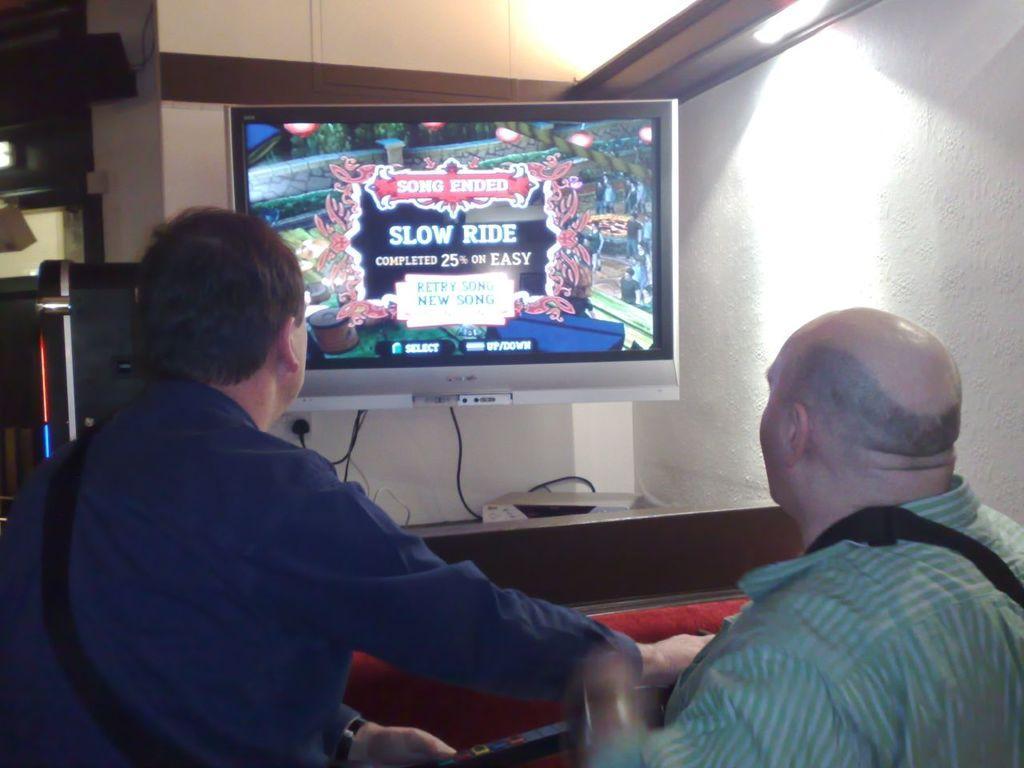Could you give a brief overview of what you see in this image? At the bottom of the picture there are two men. In the center of the picture there is a television. On the left there are some objects. At the top and left it is a wall. In the center of the picture there are cables and an electronic gadget. 